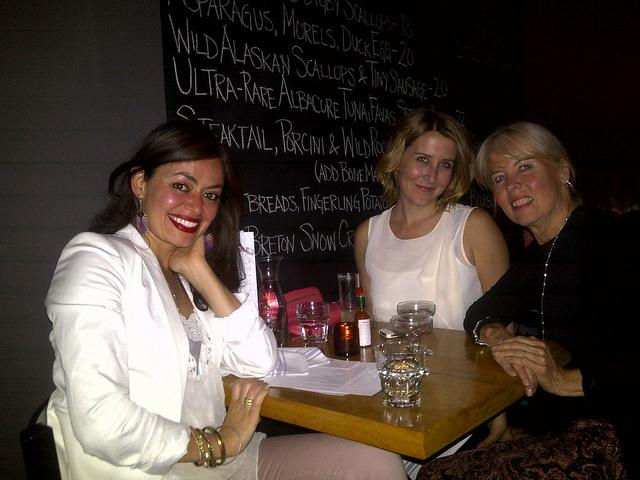What is this place? Please explain your reasoning. seafood restaurant. There are seafood names on the board. 